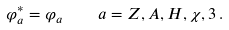Convert formula to latex. <formula><loc_0><loc_0><loc_500><loc_500>\varphi _ { a } ^ { * } = \varphi _ { a } \quad a = Z , A , H , \chi , 3 \, .</formula> 